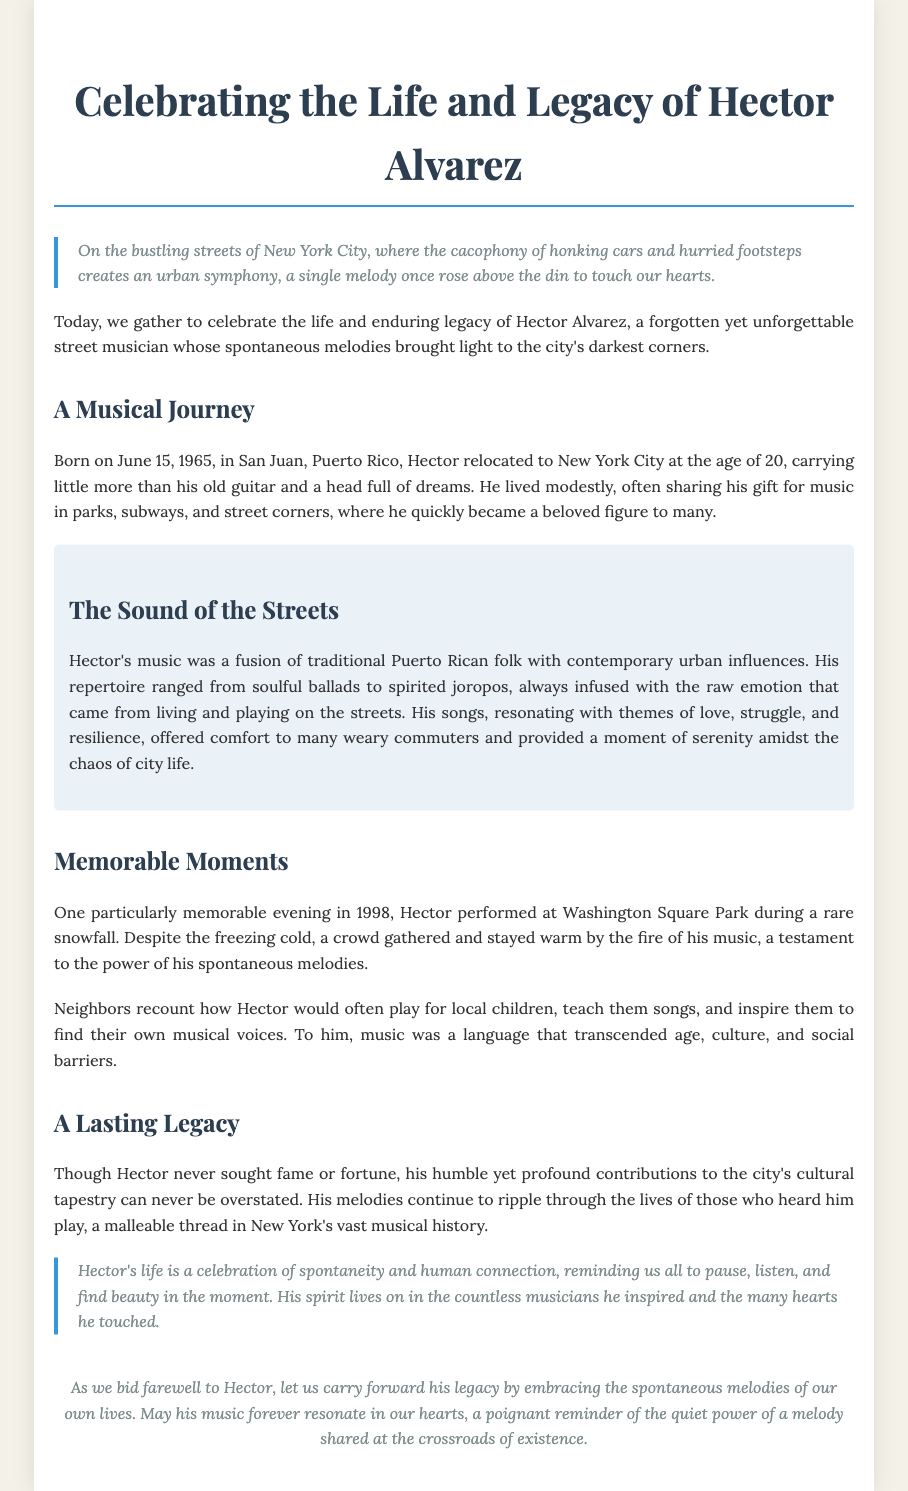What is the name of the street musician being celebrated? The name of the street musician is mentioned in the title of the eulogy as Hector Alvarez.
Answer: Hector Alvarez When was Hector Alvarez born? The document states Hector was born on June 15, 1965.
Answer: June 15, 1965 What musical styles influenced Hector's music? The document describes Hector's music as a fusion of traditional Puerto Rican folk with contemporary urban influences.
Answer: Traditional Puerto Rican folk and contemporary urban influences In what year did Hector perform at Washington Square Park during a snowfall? The document references a memorable evening in 1998 when Hector performed at Washington Square Park.
Answer: 1998 What theme is commonly found in Hector's songs? The document notes that his songs resonated with themes of love, struggle, and resilience.
Answer: Love, struggle, and resilience What does Hector's life represent according to the eulogy? The document states that Hector's life is a celebration of spontaneity and human connection.
Answer: Spontaneity and human connection How did Hector inspire local children? The document explains that Hector would often play for local children and teach them songs.
Answer: Played for local children and taught them songs What is a significant aspect of Hector's performances? The document highlights that he lived modestly and performed in parks, subways, and street corners.
Answer: Performed in parks, subways, and street corners What is the final message of the eulogy? The document concludes by encouraging us to embrace the spontaneous melodies of our own lives.
Answer: Embrace the spontaneous melodies of our own lives 